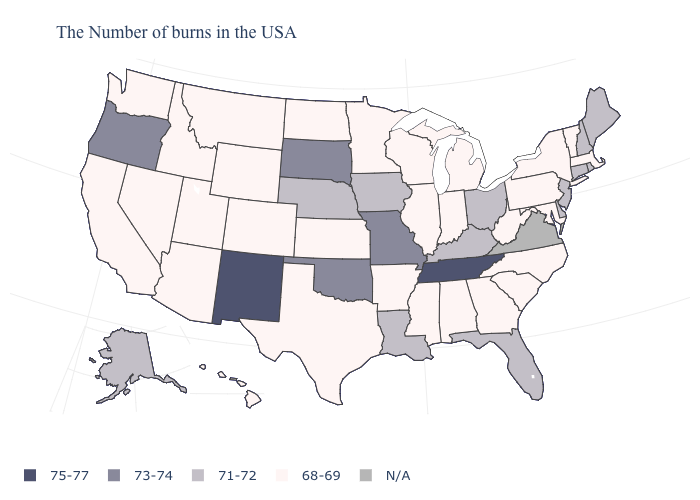Does South Dakota have the lowest value in the USA?
Be succinct. No. What is the value of Nevada?
Answer briefly. 68-69. Among the states that border Vermont , which have the lowest value?
Short answer required. Massachusetts, New York. Does Utah have the lowest value in the USA?
Give a very brief answer. Yes. What is the value of Kentucky?
Quick response, please. 71-72. Is the legend a continuous bar?
Quick response, please. No. What is the lowest value in the South?
Write a very short answer. 68-69. Name the states that have a value in the range 68-69?
Quick response, please. Massachusetts, Vermont, New York, Maryland, Pennsylvania, North Carolina, South Carolina, West Virginia, Georgia, Michigan, Indiana, Alabama, Wisconsin, Illinois, Mississippi, Arkansas, Minnesota, Kansas, Texas, North Dakota, Wyoming, Colorado, Utah, Montana, Arizona, Idaho, Nevada, California, Washington, Hawaii. Among the states that border Arkansas , which have the highest value?
Answer briefly. Tennessee. Name the states that have a value in the range 73-74?
Be succinct. Missouri, Oklahoma, South Dakota, Oregon. Does Indiana have the highest value in the MidWest?
Keep it brief. No. Does Georgia have the lowest value in the USA?
Answer briefly. Yes. What is the value of Arkansas?
Give a very brief answer. 68-69. Among the states that border South Carolina , which have the lowest value?
Write a very short answer. North Carolina, Georgia. What is the highest value in the MidWest ?
Quick response, please. 73-74. 